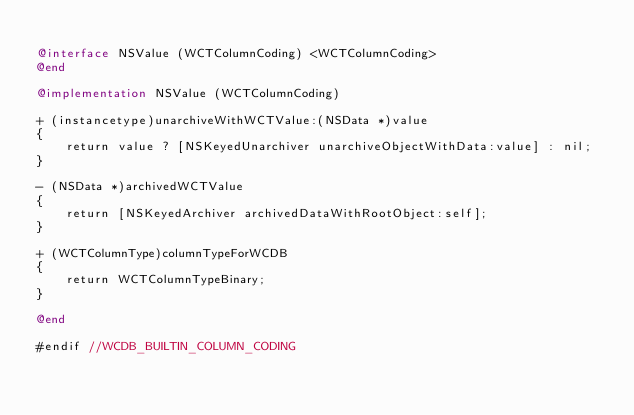Convert code to text. <code><loc_0><loc_0><loc_500><loc_500><_ObjectiveC_>
@interface NSValue (WCTColumnCoding) <WCTColumnCoding>
@end

@implementation NSValue (WCTColumnCoding)

+ (instancetype)unarchiveWithWCTValue:(NSData *)value
{
    return value ? [NSKeyedUnarchiver unarchiveObjectWithData:value] : nil;
}

- (NSData *)archivedWCTValue
{
    return [NSKeyedArchiver archivedDataWithRootObject:self];
}

+ (WCTColumnType)columnTypeForWCDB
{
    return WCTColumnTypeBinary;
}

@end

#endif //WCDB_BUILTIN_COLUMN_CODING
</code> 